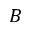Convert formula to latex. <formula><loc_0><loc_0><loc_500><loc_500>B</formula> 